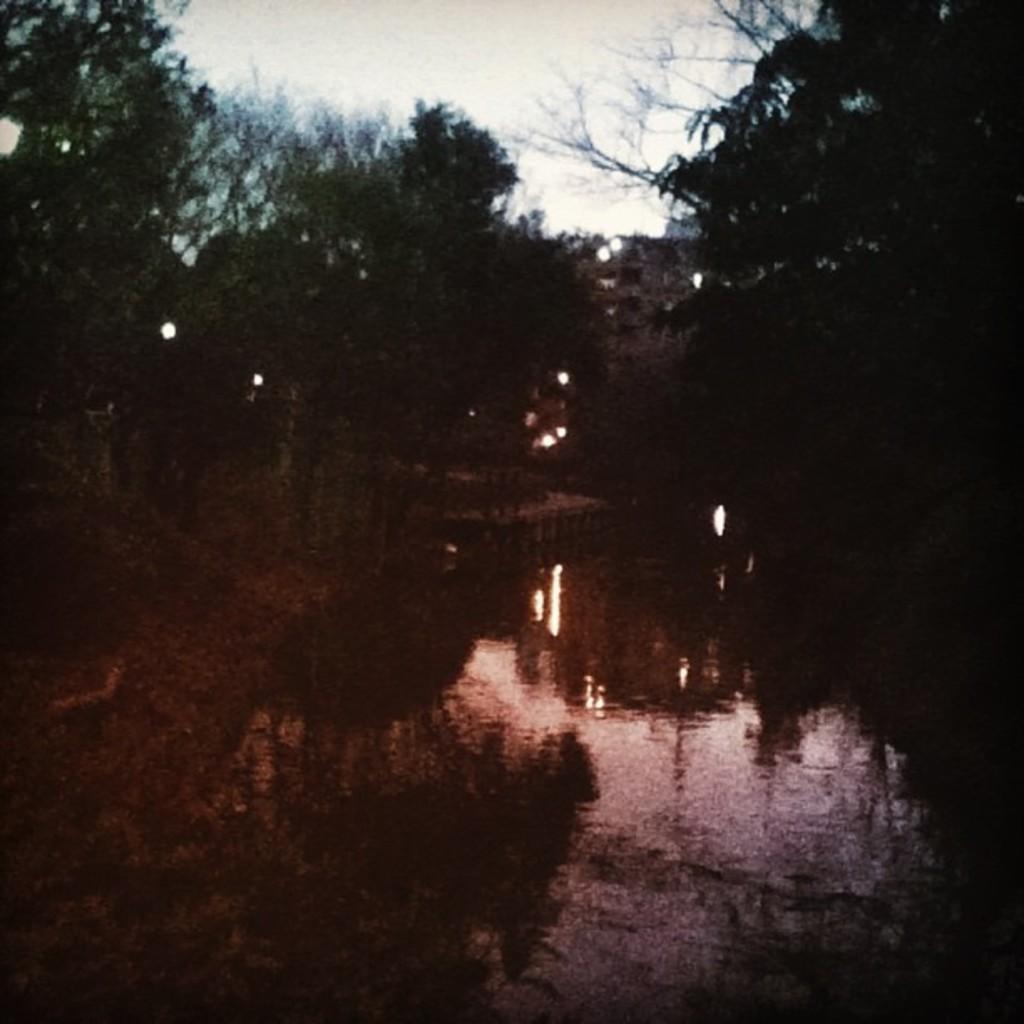In one or two sentences, can you explain what this image depicts? In this image, we can see a lake. There are trees in the middle of the image. There is a sky at the top of the image. 